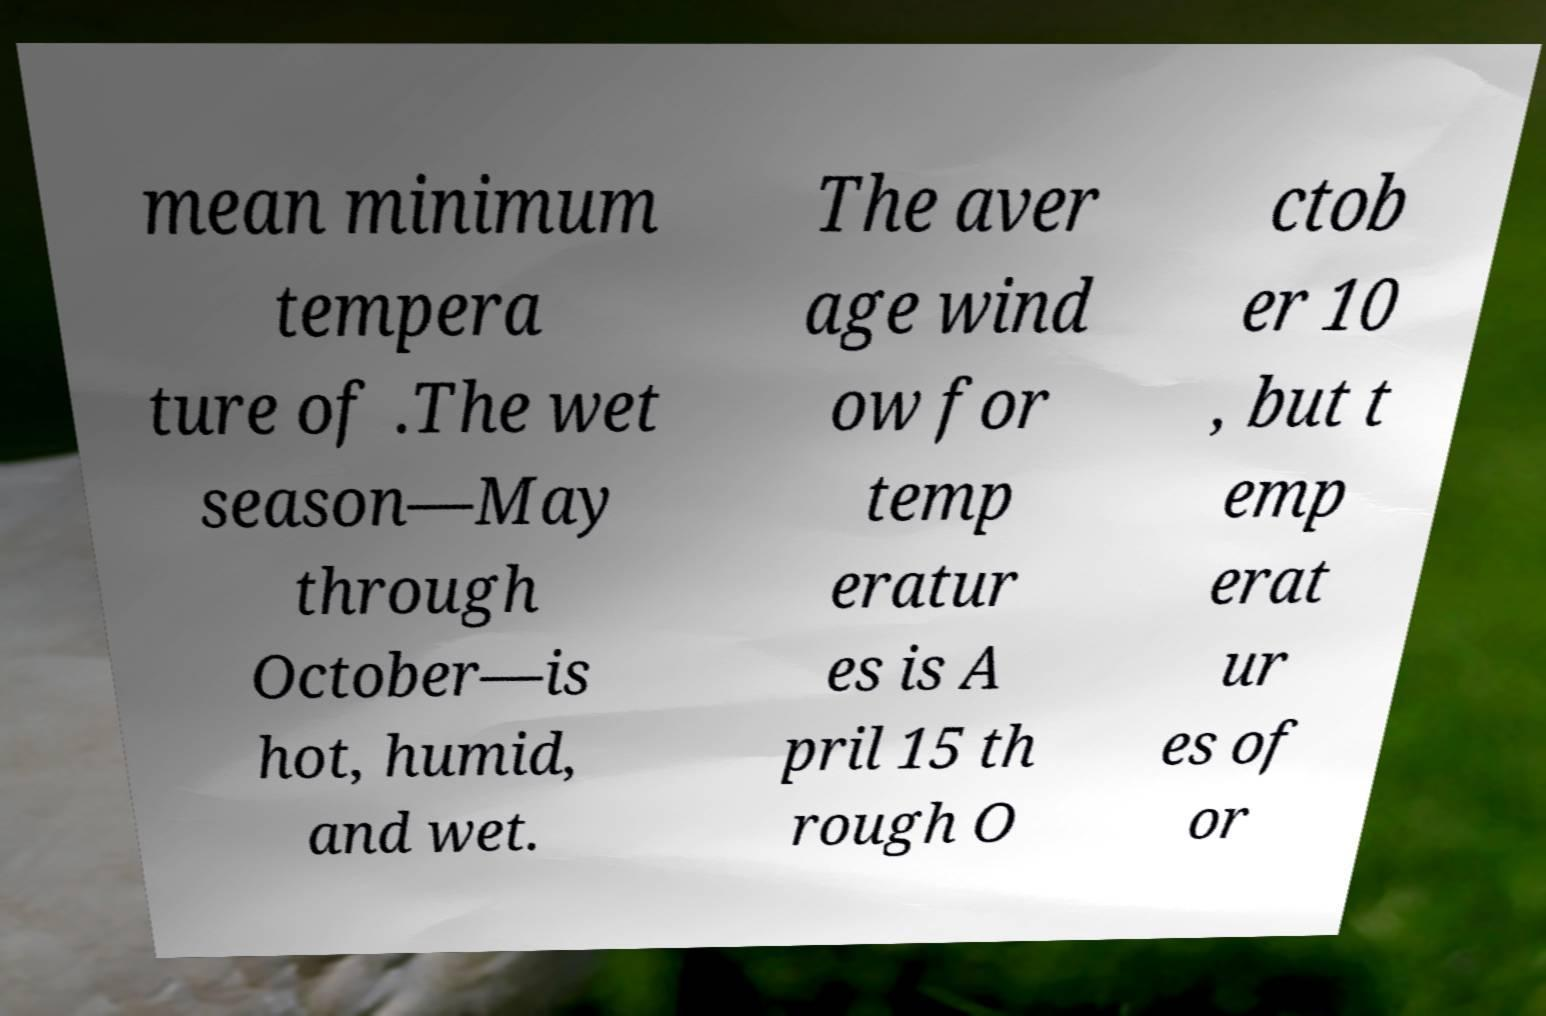What messages or text are displayed in this image? I need them in a readable, typed format. mean minimum tempera ture of .The wet season—May through October—is hot, humid, and wet. The aver age wind ow for temp eratur es is A pril 15 th rough O ctob er 10 , but t emp erat ur es of or 